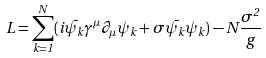Convert formula to latex. <formula><loc_0><loc_0><loc_500><loc_500>L = \sum _ { k = 1 } ^ { N } ( i \bar { \psi _ { k } } \gamma ^ { \mu } \partial _ { \mu } \psi _ { k } + \sigma \bar { \psi _ { k } } \psi _ { k } ) - N \frac { \sigma ^ { 2 } } { g }</formula> 